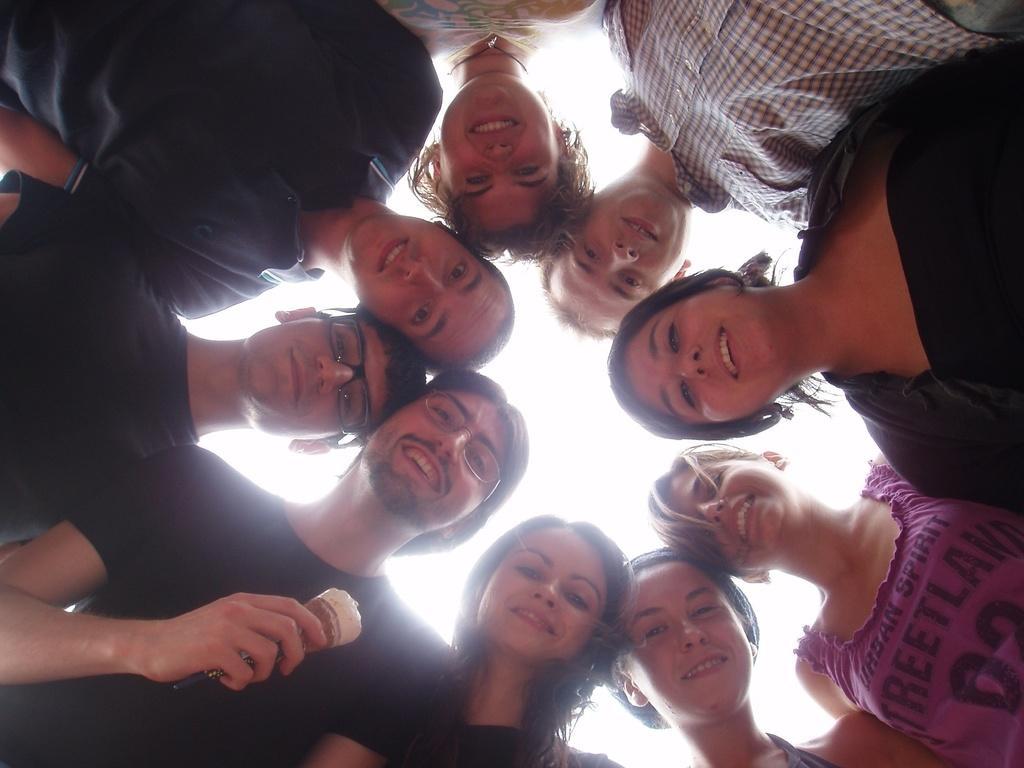Describe this image in one or two sentences. In this image we can see people in the circle. They are all smiling. The man standing on the left is holding an ice cream. In the background there is sky. 